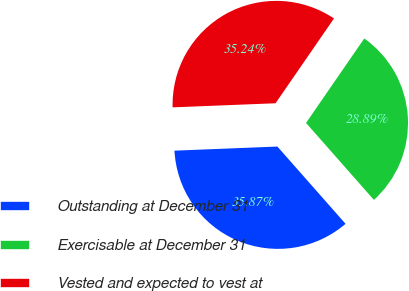Convert chart. <chart><loc_0><loc_0><loc_500><loc_500><pie_chart><fcel>Outstanding at December 31<fcel>Exercisable at December 31<fcel>Vested and expected to vest at<nl><fcel>35.87%<fcel>28.89%<fcel>35.24%<nl></chart> 